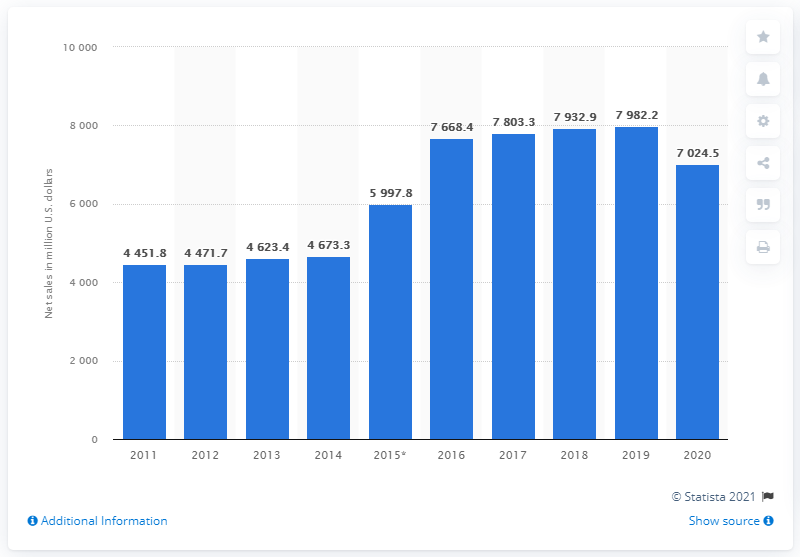Indicate a few pertinent items in this graphic. In 2016, the year that saw the highest sales compared to the previous year was... The average of the first four sales is 4555.05. 